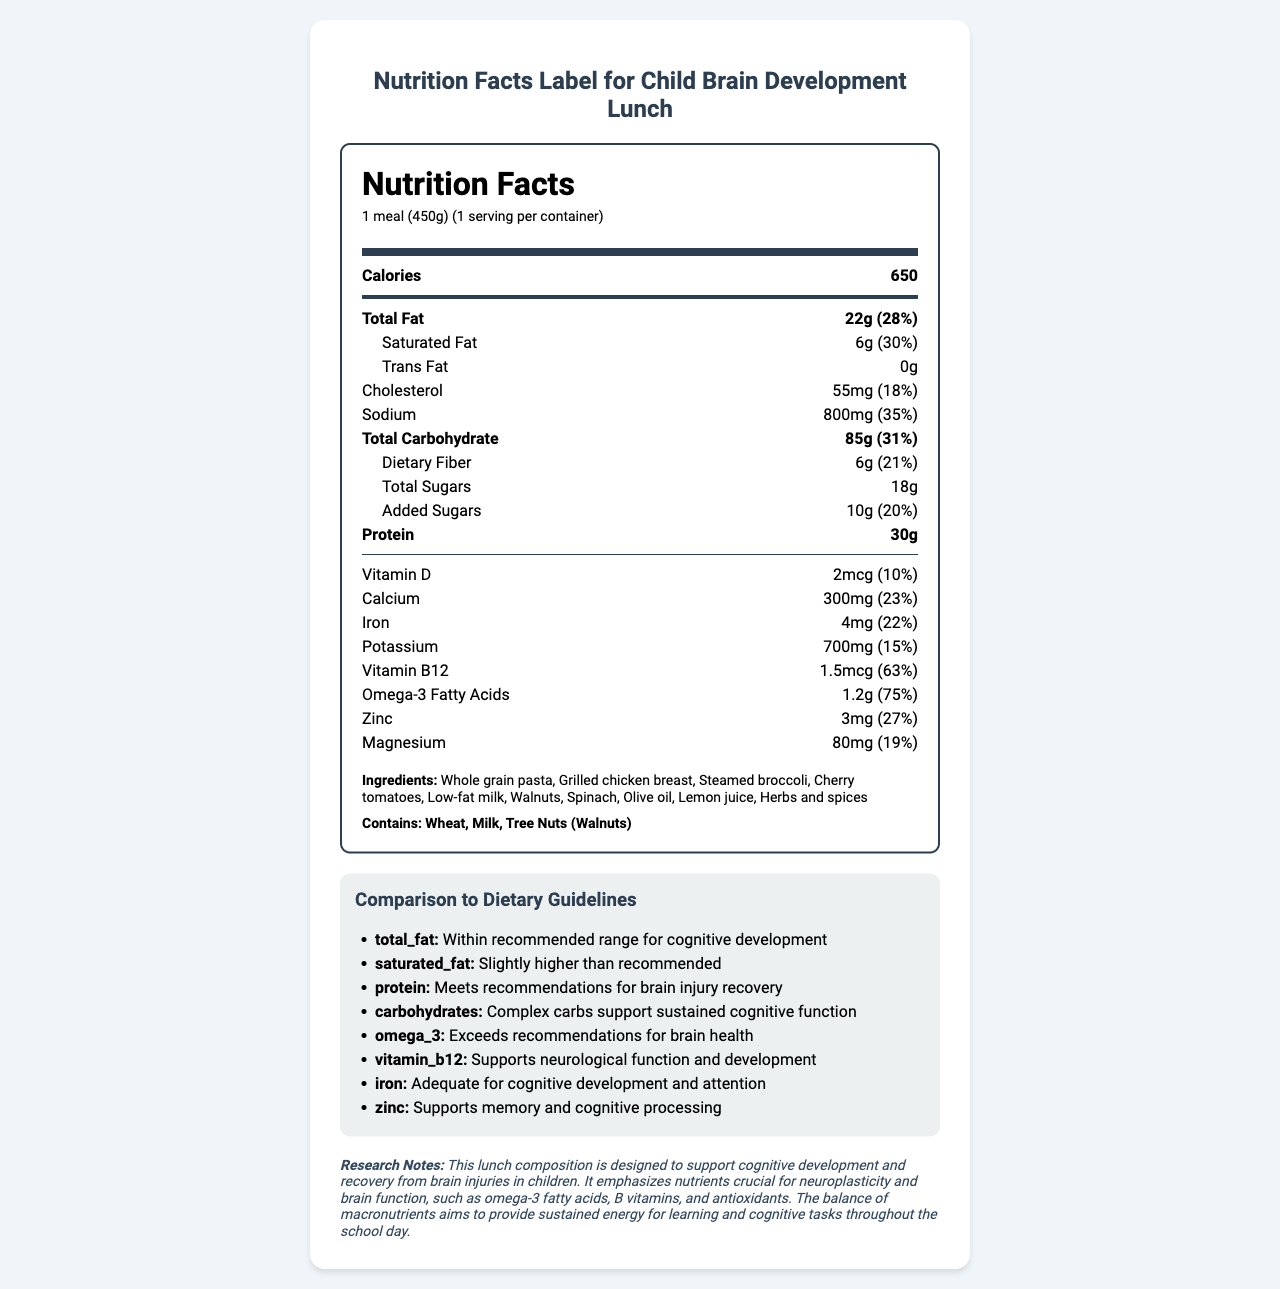what is the serving size? The serving size is listed in the header section of the Nutrition Facts label as "1 meal (450g)".
Answer: 1 meal (450g) How many calories does one serving contain? The document states at the top of the Nutrition Facts section that one serving contains 650 calories.
Answer: 650 What is the total amount of fat in one serving? The document lists the total fat content in one serving as 22g, which is displayed prominently in the Nutrition Facts panel.
Answer: 22g What nutrients are particularly highlighted for brain development in this lunch? In the comparison to dietary guidelines section, these nutrients are highlighted for their importance in brain health and cognitive development.
Answer: Omega-3 fatty acids, Vitamin B12, Iron, Zinc What percentage of the daily recommended intake of Omega-3 fatty acids does this meal contain? The Nutrition Facts label specifies that the meal provides 75% of the daily recommended intake of Omega-3 fatty acids.
Answer: 75% Does this lunch contain any trans fat? The Nutrition Facts label lists the amount of trans fat as 0g.
Answer: No Which of the following ingredients are included in the meal? A. Quinoa B. Grilled chicken breast C. Almonds The ingredients list includes grilled chicken breast but does not mention quinoa or almonds.
Answer: B Is the amount of saturated fat in the lunch within the recommended range for cognitive development? According to the comparison to guidelines, the amount of saturated fat is slightly higher than recommended for cognitive development.
Answer: No, it is slightly higher than recommended. What allergens are present in this meal? The allergen information section states that the meal contains wheat, milk, and tree nuts (walnuts).
Answer: Wheat, Milk, Tree Nuts (Walnuts) What is the main purpose of this specific lunch design according to the research notes? The research notes explain that the lunch composition is designed to support cognitive development and recovery from brain injuries in children.
Answer: To support cognitive development and recovery from brain injuries in children What percentage of the daily value of iron does this meal provide? The Nutrition Facts label shows that this meal provides 22% of the daily value of iron.
Answer: 22% Can the amount of Vitamin D in this meal be considered sufficient for cognitive development needs? The document does not specify the recommended daily amount of Vitamin D for cognitive development.
Answer: Cannot be determined How does the protein content in this meal compare to the recommendations for brain injury recovery? The comparison to guidelines section indicates that the protein content meets recommendations for brain injury recovery.
Answer: Meets recommendations Is the total carbohydrate content primarily composed of complex carbohydrates? According to the comparison to guidelines section, the carbohydrates are complex and support sustained cognitive function.
Answer: Yes Compared to the recommended daily intake, how much dietary fiber does this meal provide? A. 15% B. 21% C. 10% The Nutrition Facts label indicates that the meal provides 21% of the daily value of dietary fiber.
Answer: B What is the main idea of this document? The document includes nutritional information, ingredients, allergens, comparison to dietary guidelines, and research notes explaining the benefits of the nutrients included in the meal.
Answer: The document provides a detailed Nutrition Facts label for a specially designed school lunch aimed at supporting child brain development and recovery from brain injuries. What does the "added sugars" amount in the lunch tell us about its nutritional quality? The label states that the lunch contains 10g of added sugars, which account for 20% of the daily intake, giving insight into the sugar content relative to dietary recommendations.
Answer: It contains 10g of added sugars, which is 20% of the daily value. 